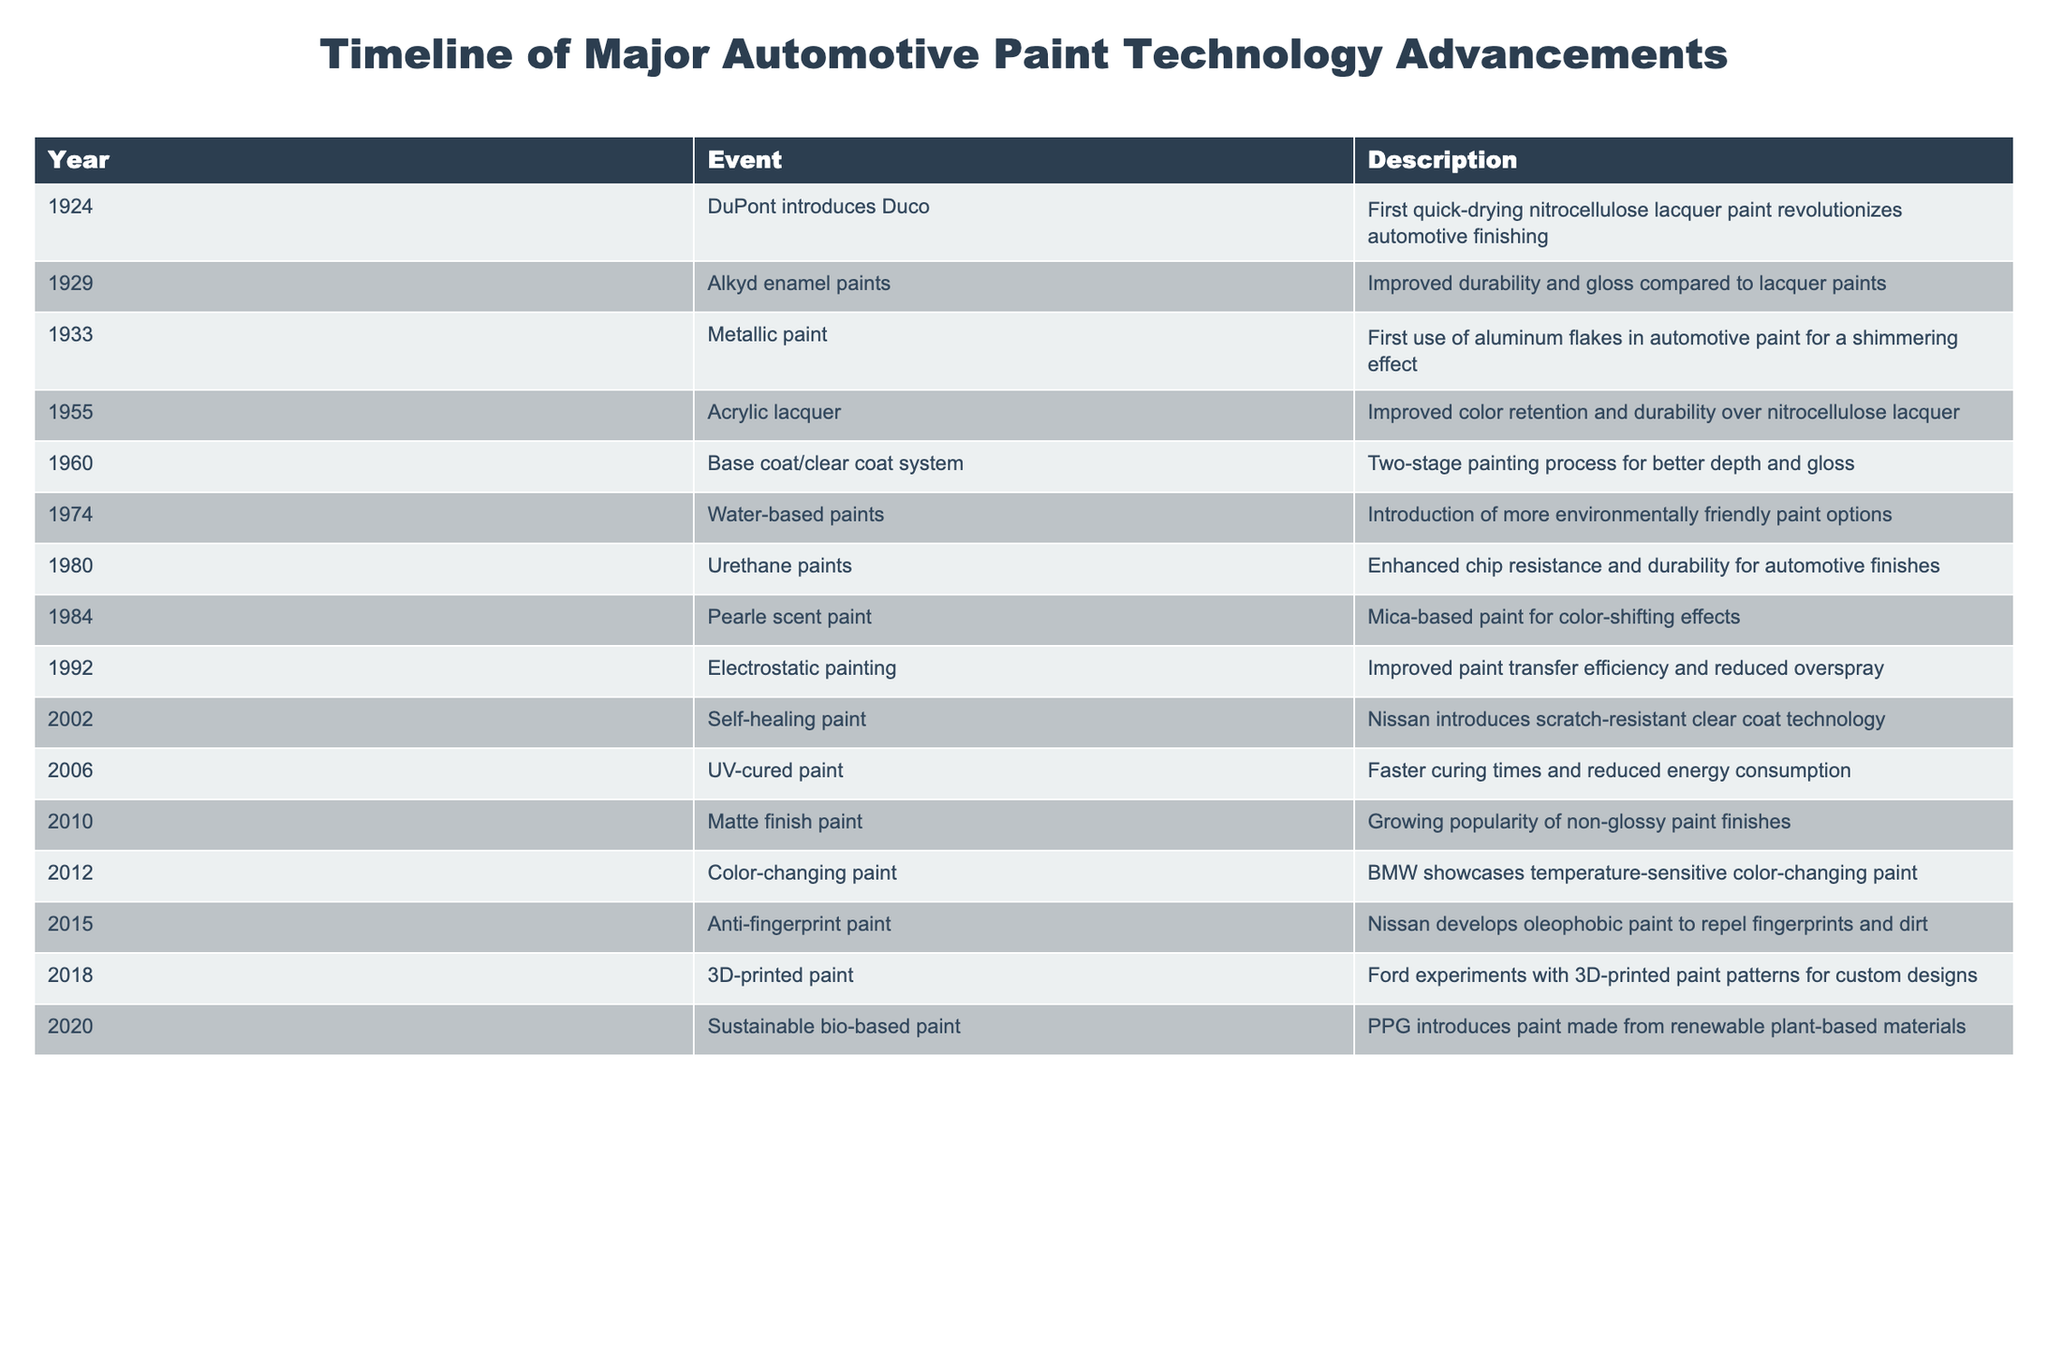What significant advancement in automotive paint occurred in 1924? The table lists an event in 1924 where DuPont introduced Duco, which was the first quick-drying nitrocellulose lacquer paint. This was a major shift in automotive finishing.
Answer: DuPont introduces Duco What year did the use of metallic paint first occur? According to the table, the first use of metallic paint happened in 1933, where aluminum flakes were incorporated for a shimmering effect.
Answer: 1933 Which paint technology introduced in 1974 focused on environmental concerns? The table indicates that in 1974, water-based paints were introduced, aimed at being more environmentally friendly compared to previous options.
Answer: Water-based paints True or False: The base coat/clear coat system was introduced before acrylic lacquer. By examining the years for these two events in the table, the base coat/clear coat system was introduced in 1960, while acrylic lacquer was introduced in 1955. Since 1960 is after 1955, the statement is false.
Answer: False Which innovation in paint technology was developed by Nissan in 2002? The table notes that in 2002, Nissan introduced self-healing paint that features scratch-resistant clear coat technology.
Answer: Self-healing paint What are the two major advancements in automotive paint technology introduced in 2012? The table lists two events for 2012: one was the color-changing paint by BMW, and the other does not mention significant advancements for that year. Therefore, only one major advancement is noted for 2012.
Answer: Color-changing paint What is the average year of introduction for environmentally friendly paint technologies from the table? The table highlights two events concerning environmentally friendly paints: water-based paints (1974) and sustainable bio-based paint (2020). The average year can be calculated as (1974 + 2020) / 2 = 1997.
Answer: 1997 How many years passed between the introduction of urethane paints and UV-cured paint? Urethane paints were introduced in 1980, and UV-cured paint was introduced in 2006. Calculating the difference gives 2006 - 1980 = 26 years.
Answer: 26 years What was the defining feature of mica-based paint introduced in 1984? The table states that in 1984, pearlescent paint was introduced, which is characterized by its color-shifting effects due to the mica content.
Answer: Color-shifting effects 